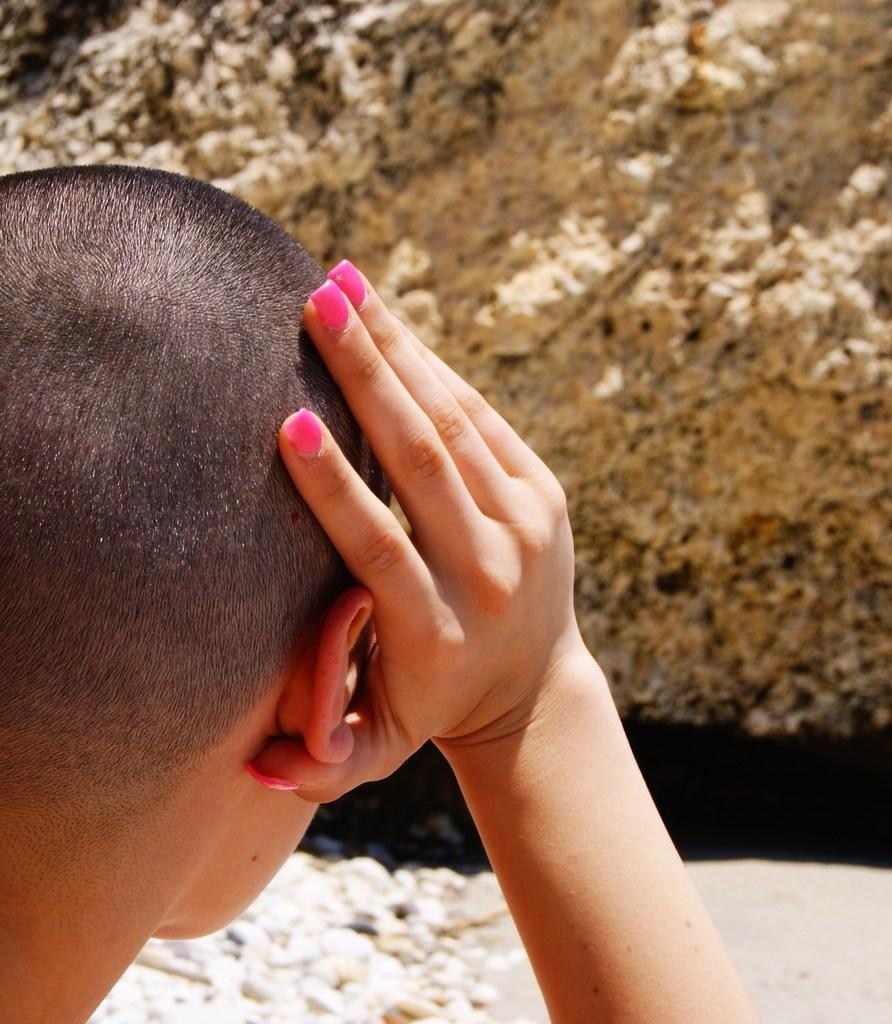Who or what is present in the image? There is a person in the image. What can be seen in the background of the image? There is a rock in the background of the image. How many ants are crawling on the person in the image? There are no ants present in the image; only a person and a rock in the background can be seen. 